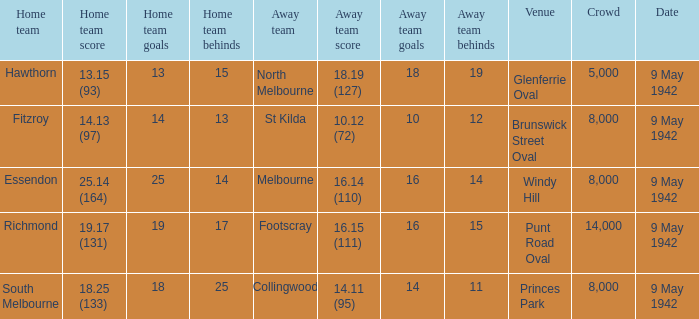How large was the crowd with a home team score of 18.25 (133)? 8000.0. 